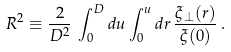<formula> <loc_0><loc_0><loc_500><loc_500>R ^ { 2 } \equiv \frac { 2 } { D ^ { 2 } } \, \int _ { 0 } ^ { D } d u \int _ { 0 } ^ { u } d r \, \frac { \xi _ { \bot } ( r ) } { \xi ( 0 ) } \, .</formula> 